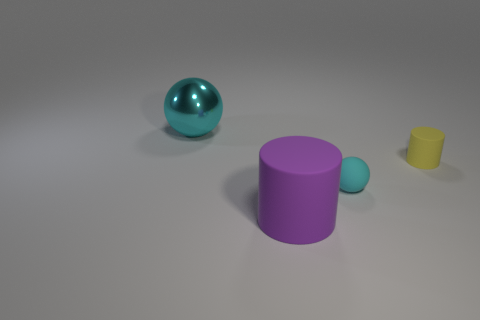How many other things are the same size as the cyan metallic sphere?
Ensure brevity in your answer.  1. There is a cylinder that is in front of the tiny yellow thing; what material is it?
Ensure brevity in your answer.  Rubber. Does the yellow object have the same shape as the tiny cyan rubber object?
Make the answer very short. No. What number of other objects are there of the same shape as the small cyan matte object?
Offer a terse response. 1. There is a object that is behind the yellow object; what is its color?
Provide a succinct answer. Cyan. Is the size of the purple cylinder the same as the yellow rubber cylinder?
Give a very brief answer. No. What material is the cyan object behind the cylinder behind the big purple cylinder made of?
Ensure brevity in your answer.  Metal. How many other big balls are the same color as the metal sphere?
Offer a terse response. 0. Is there anything else that has the same material as the tiny cylinder?
Your answer should be compact. Yes. Is the number of matte things to the left of the small cyan matte sphere less than the number of blue things?
Your answer should be compact. No. 